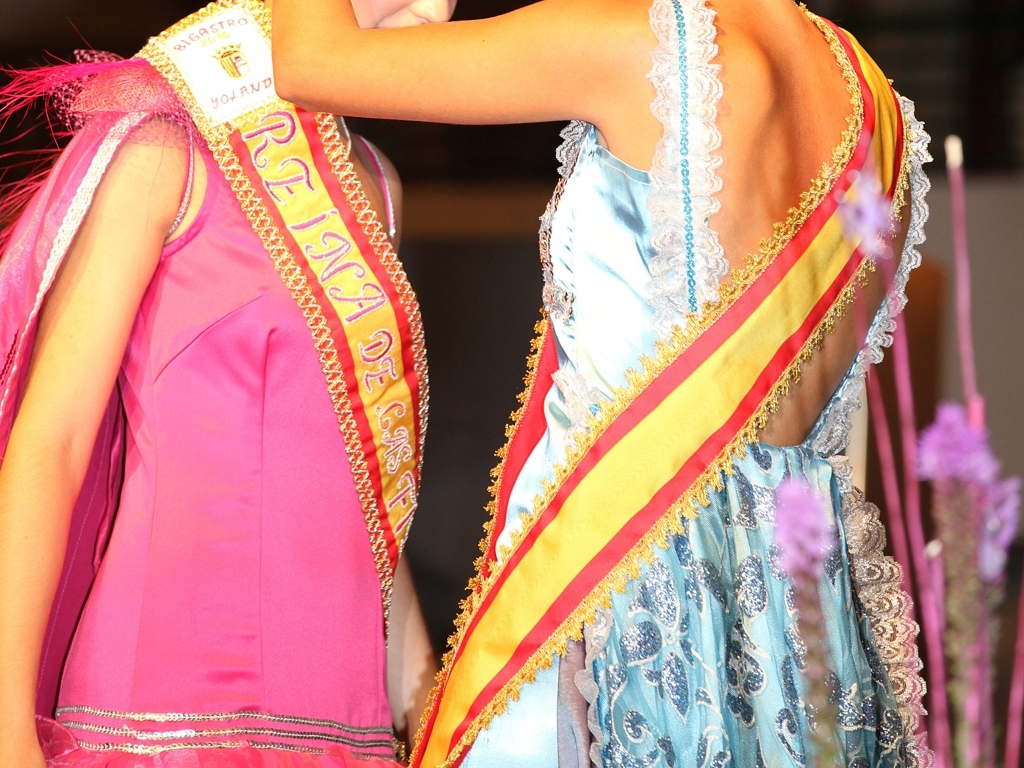What is the overall clarity of this image?
A. The overall clarity of this image is high.
B. The overall clarity of this image is low.
Answer with the option's letter from the given choices directly.
 A. 